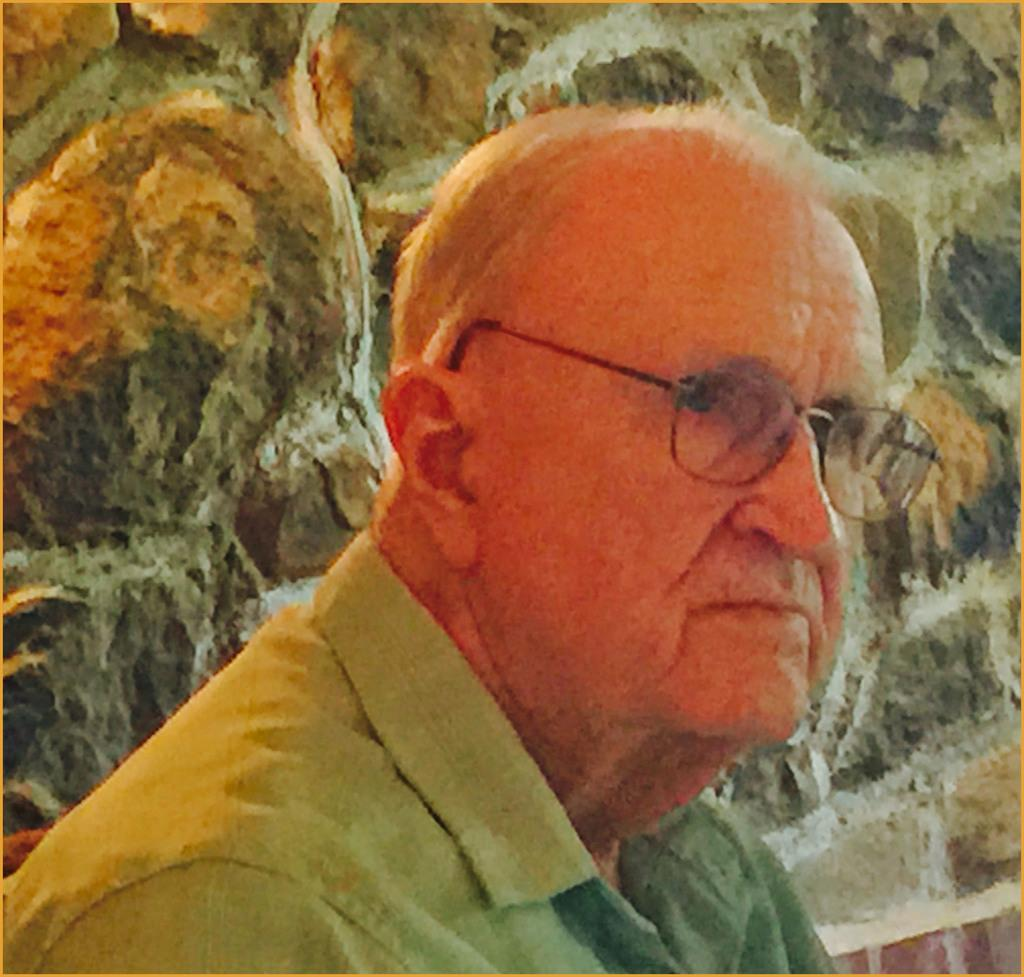Who is the main subject in the image? There is an old man in the image. What is the old man doing in the image? The old man is looking to the right. What is the old man wearing in the image? The old man is wearing a shirt and spectacles. What can be seen at the top of the image? There is a stone wall at the top of the image. What word is written in the notebook that the old man is holding in the image? There is no notebook present in the image, and therefore no word can be read. 